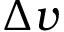Convert formula to latex. <formula><loc_0><loc_0><loc_500><loc_500>\Delta v</formula> 